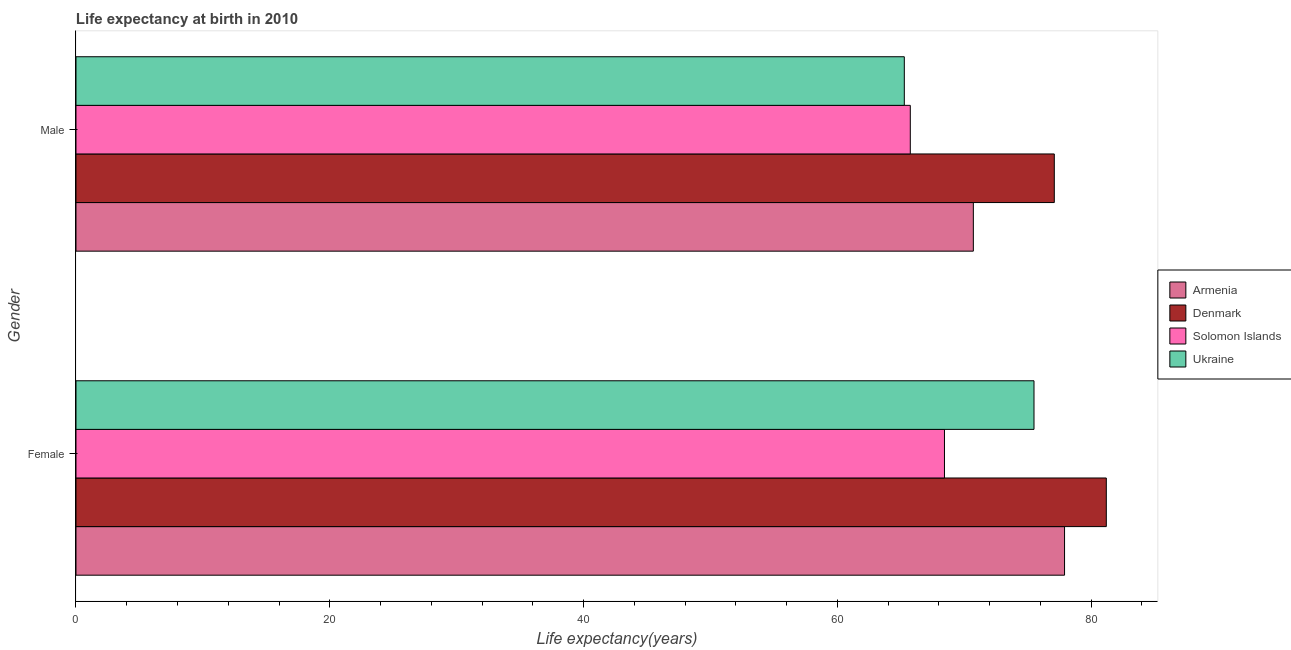How many groups of bars are there?
Ensure brevity in your answer.  2. Are the number of bars per tick equal to the number of legend labels?
Make the answer very short. Yes. Are the number of bars on each tick of the Y-axis equal?
Keep it short and to the point. Yes. What is the label of the 2nd group of bars from the top?
Make the answer very short. Female. What is the life expectancy(male) in Solomon Islands?
Keep it short and to the point. 65.75. Across all countries, what is the maximum life expectancy(male)?
Offer a very short reply. 77.1. Across all countries, what is the minimum life expectancy(male)?
Ensure brevity in your answer.  65.28. In which country was the life expectancy(female) minimum?
Your answer should be compact. Solomon Islands. What is the total life expectancy(female) in the graph?
Ensure brevity in your answer.  303.05. What is the difference between the life expectancy(female) in Denmark and that in Armenia?
Give a very brief answer. 3.29. What is the difference between the life expectancy(female) in Ukraine and the life expectancy(male) in Solomon Islands?
Your answer should be compact. 9.75. What is the average life expectancy(male) per country?
Your response must be concise. 69.71. What is the difference between the life expectancy(female) and life expectancy(male) in Denmark?
Offer a terse response. 4.1. In how many countries, is the life expectancy(male) greater than 56 years?
Give a very brief answer. 4. What is the ratio of the life expectancy(male) in Solomon Islands to that in Armenia?
Your answer should be compact. 0.93. Is the life expectancy(male) in Denmark less than that in Ukraine?
Your answer should be very brief. No. What does the 2nd bar from the top in Male represents?
Give a very brief answer. Solomon Islands. What does the 4th bar from the bottom in Female represents?
Give a very brief answer. Ukraine. How many bars are there?
Keep it short and to the point. 8. Are all the bars in the graph horizontal?
Your answer should be very brief. Yes. How many countries are there in the graph?
Provide a short and direct response. 4. What is the difference between two consecutive major ticks on the X-axis?
Make the answer very short. 20. Does the graph contain grids?
Offer a terse response. No. How many legend labels are there?
Provide a succinct answer. 4. How are the legend labels stacked?
Offer a terse response. Vertical. What is the title of the graph?
Provide a short and direct response. Life expectancy at birth in 2010. Does "Tuvalu" appear as one of the legend labels in the graph?
Ensure brevity in your answer.  No. What is the label or title of the X-axis?
Your answer should be compact. Life expectancy(years). What is the Life expectancy(years) in Armenia in Female?
Ensure brevity in your answer.  77.91. What is the Life expectancy(years) of Denmark in Female?
Provide a succinct answer. 81.2. What is the Life expectancy(years) in Solomon Islands in Female?
Give a very brief answer. 68.44. What is the Life expectancy(years) of Ukraine in Female?
Your response must be concise. 75.5. What is the Life expectancy(years) of Armenia in Male?
Provide a succinct answer. 70.72. What is the Life expectancy(years) of Denmark in Male?
Your answer should be compact. 77.1. What is the Life expectancy(years) in Solomon Islands in Male?
Provide a short and direct response. 65.75. What is the Life expectancy(years) in Ukraine in Male?
Your response must be concise. 65.28. Across all Gender, what is the maximum Life expectancy(years) of Armenia?
Offer a terse response. 77.91. Across all Gender, what is the maximum Life expectancy(years) in Denmark?
Give a very brief answer. 81.2. Across all Gender, what is the maximum Life expectancy(years) of Solomon Islands?
Provide a succinct answer. 68.44. Across all Gender, what is the maximum Life expectancy(years) in Ukraine?
Ensure brevity in your answer.  75.5. Across all Gender, what is the minimum Life expectancy(years) in Armenia?
Offer a terse response. 70.72. Across all Gender, what is the minimum Life expectancy(years) of Denmark?
Keep it short and to the point. 77.1. Across all Gender, what is the minimum Life expectancy(years) of Solomon Islands?
Offer a terse response. 65.75. Across all Gender, what is the minimum Life expectancy(years) of Ukraine?
Provide a short and direct response. 65.28. What is the total Life expectancy(years) of Armenia in the graph?
Offer a very short reply. 148.63. What is the total Life expectancy(years) of Denmark in the graph?
Ensure brevity in your answer.  158.3. What is the total Life expectancy(years) of Solomon Islands in the graph?
Your answer should be very brief. 134.2. What is the total Life expectancy(years) in Ukraine in the graph?
Keep it short and to the point. 140.78. What is the difference between the Life expectancy(years) in Armenia in Female and that in Male?
Offer a terse response. 7.19. What is the difference between the Life expectancy(years) in Denmark in Female and that in Male?
Your response must be concise. 4.1. What is the difference between the Life expectancy(years) of Solomon Islands in Female and that in Male?
Keep it short and to the point. 2.69. What is the difference between the Life expectancy(years) of Ukraine in Female and that in Male?
Your answer should be very brief. 10.22. What is the difference between the Life expectancy(years) of Armenia in Female and the Life expectancy(years) of Denmark in Male?
Provide a succinct answer. 0.81. What is the difference between the Life expectancy(years) of Armenia in Female and the Life expectancy(years) of Solomon Islands in Male?
Provide a succinct answer. 12.16. What is the difference between the Life expectancy(years) in Armenia in Female and the Life expectancy(years) in Ukraine in Male?
Keep it short and to the point. 12.63. What is the difference between the Life expectancy(years) in Denmark in Female and the Life expectancy(years) in Solomon Islands in Male?
Give a very brief answer. 15.45. What is the difference between the Life expectancy(years) in Denmark in Female and the Life expectancy(years) in Ukraine in Male?
Keep it short and to the point. 15.92. What is the difference between the Life expectancy(years) of Solomon Islands in Female and the Life expectancy(years) of Ukraine in Male?
Your answer should be compact. 3.17. What is the average Life expectancy(years) in Armenia per Gender?
Offer a terse response. 74.31. What is the average Life expectancy(years) in Denmark per Gender?
Keep it short and to the point. 79.15. What is the average Life expectancy(years) of Solomon Islands per Gender?
Make the answer very short. 67.1. What is the average Life expectancy(years) of Ukraine per Gender?
Give a very brief answer. 70.39. What is the difference between the Life expectancy(years) of Armenia and Life expectancy(years) of Denmark in Female?
Offer a very short reply. -3.29. What is the difference between the Life expectancy(years) of Armenia and Life expectancy(years) of Solomon Islands in Female?
Give a very brief answer. 9.46. What is the difference between the Life expectancy(years) in Armenia and Life expectancy(years) in Ukraine in Female?
Offer a terse response. 2.41. What is the difference between the Life expectancy(years) of Denmark and Life expectancy(years) of Solomon Islands in Female?
Offer a very short reply. 12.76. What is the difference between the Life expectancy(years) of Solomon Islands and Life expectancy(years) of Ukraine in Female?
Your response must be concise. -7.05. What is the difference between the Life expectancy(years) of Armenia and Life expectancy(years) of Denmark in Male?
Keep it short and to the point. -6.38. What is the difference between the Life expectancy(years) in Armenia and Life expectancy(years) in Solomon Islands in Male?
Keep it short and to the point. 4.97. What is the difference between the Life expectancy(years) of Armenia and Life expectancy(years) of Ukraine in Male?
Give a very brief answer. 5.44. What is the difference between the Life expectancy(years) of Denmark and Life expectancy(years) of Solomon Islands in Male?
Your answer should be very brief. 11.35. What is the difference between the Life expectancy(years) of Denmark and Life expectancy(years) of Ukraine in Male?
Your response must be concise. 11.82. What is the difference between the Life expectancy(years) in Solomon Islands and Life expectancy(years) in Ukraine in Male?
Offer a very short reply. 0.47. What is the ratio of the Life expectancy(years) in Armenia in Female to that in Male?
Provide a short and direct response. 1.1. What is the ratio of the Life expectancy(years) in Denmark in Female to that in Male?
Provide a short and direct response. 1.05. What is the ratio of the Life expectancy(years) of Solomon Islands in Female to that in Male?
Your answer should be compact. 1.04. What is the ratio of the Life expectancy(years) of Ukraine in Female to that in Male?
Your answer should be very brief. 1.16. What is the difference between the highest and the second highest Life expectancy(years) in Armenia?
Ensure brevity in your answer.  7.19. What is the difference between the highest and the second highest Life expectancy(years) of Denmark?
Ensure brevity in your answer.  4.1. What is the difference between the highest and the second highest Life expectancy(years) in Solomon Islands?
Your response must be concise. 2.69. What is the difference between the highest and the second highest Life expectancy(years) of Ukraine?
Your answer should be compact. 10.22. What is the difference between the highest and the lowest Life expectancy(years) in Armenia?
Provide a succinct answer. 7.19. What is the difference between the highest and the lowest Life expectancy(years) of Solomon Islands?
Offer a terse response. 2.69. What is the difference between the highest and the lowest Life expectancy(years) in Ukraine?
Give a very brief answer. 10.22. 